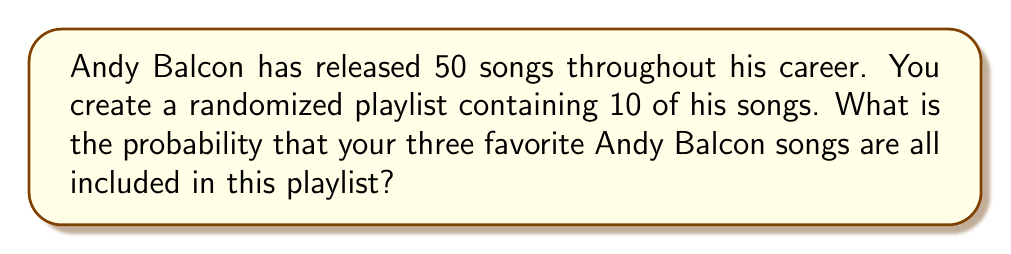Could you help me with this problem? Let's approach this step-by-step:

1) First, we need to consider how many ways we can choose 10 songs from 50. This is a combination problem, denoted as $\binom{50}{10}$.

2) Now, we need to ensure that the three favorite songs are included. This means we only need to choose 7 more songs from the remaining 47.

3) The number of ways to choose 7 songs from 47 is $\binom{47}{7}$.

4) The probability is then the number of favorable outcomes divided by the total number of possible outcomes:

   $$P(\text{3 favorite songs included}) = \frac{\binom{47}{7}}{\binom{50}{10}}$$

5) Let's calculate these values:
   
   $$\binom{50}{10} = \frac{50!}{10!(50-10)!} = \frac{50!}{10!40!} = 10,272,278,170$$
   
   $$\binom{47}{7} = \frac{47!}{7!(47-7)!} = \frac{47!}{7!40!} = 62,009,460$$

6) Now we can calculate the probability:

   $$P = \frac{62,009,460}{10,272,278,170} \approx 0.00603762$$
Answer: $\frac{62,009,460}{10,272,278,170}$ or approximately 0.00604 